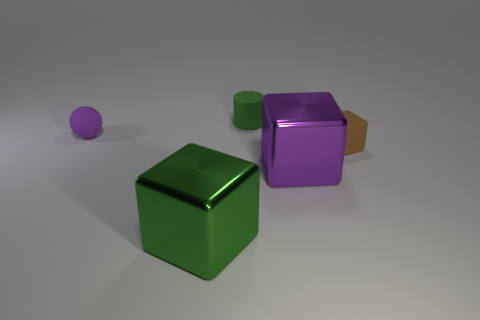Add 2 balls. How many objects exist? 7 Subtract all balls. How many objects are left? 4 Subtract all large green rubber things. Subtract all brown matte things. How many objects are left? 4 Add 4 big metal blocks. How many big metal blocks are left? 6 Add 2 small matte cubes. How many small matte cubes exist? 3 Subtract 0 cyan cylinders. How many objects are left? 5 